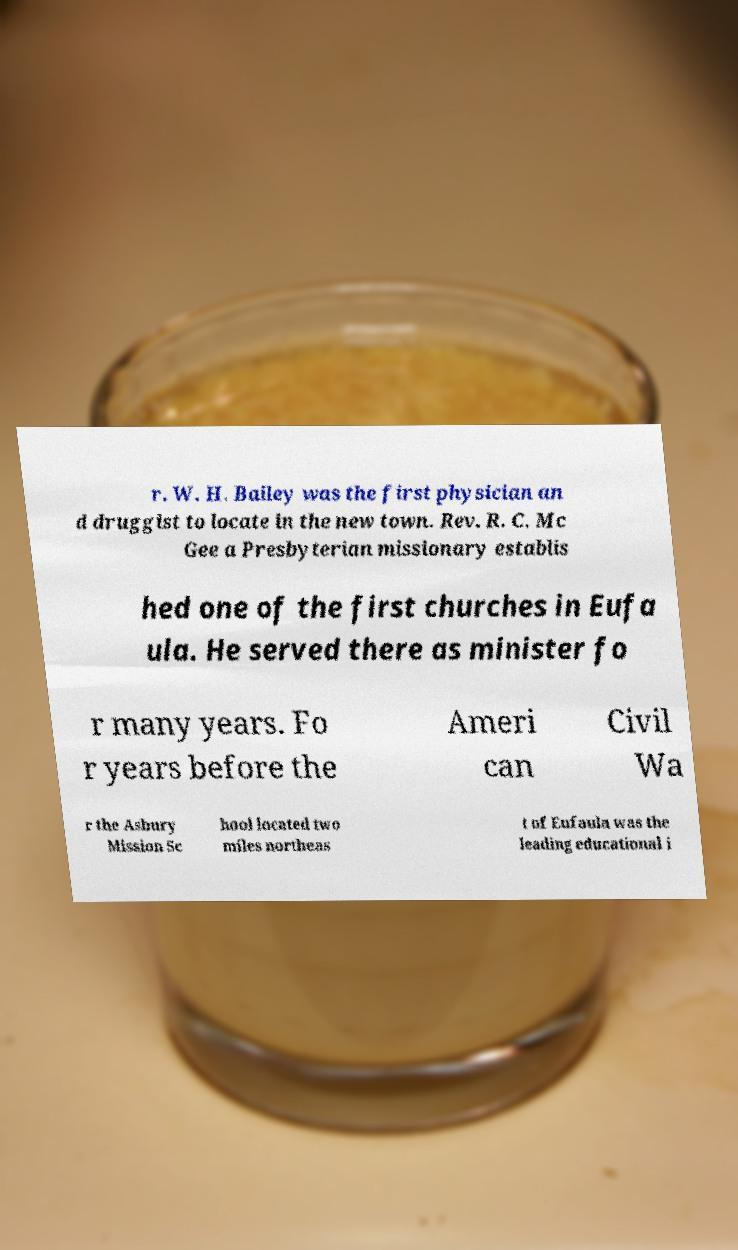There's text embedded in this image that I need extracted. Can you transcribe it verbatim? r. W. H. Bailey was the first physician an d druggist to locate in the new town. Rev. R. C. Mc Gee a Presbyterian missionary establis hed one of the first churches in Eufa ula. He served there as minister fo r many years. Fo r years before the Ameri can Civil Wa r the Asbury Mission Sc hool located two miles northeas t of Eufaula was the leading educational i 